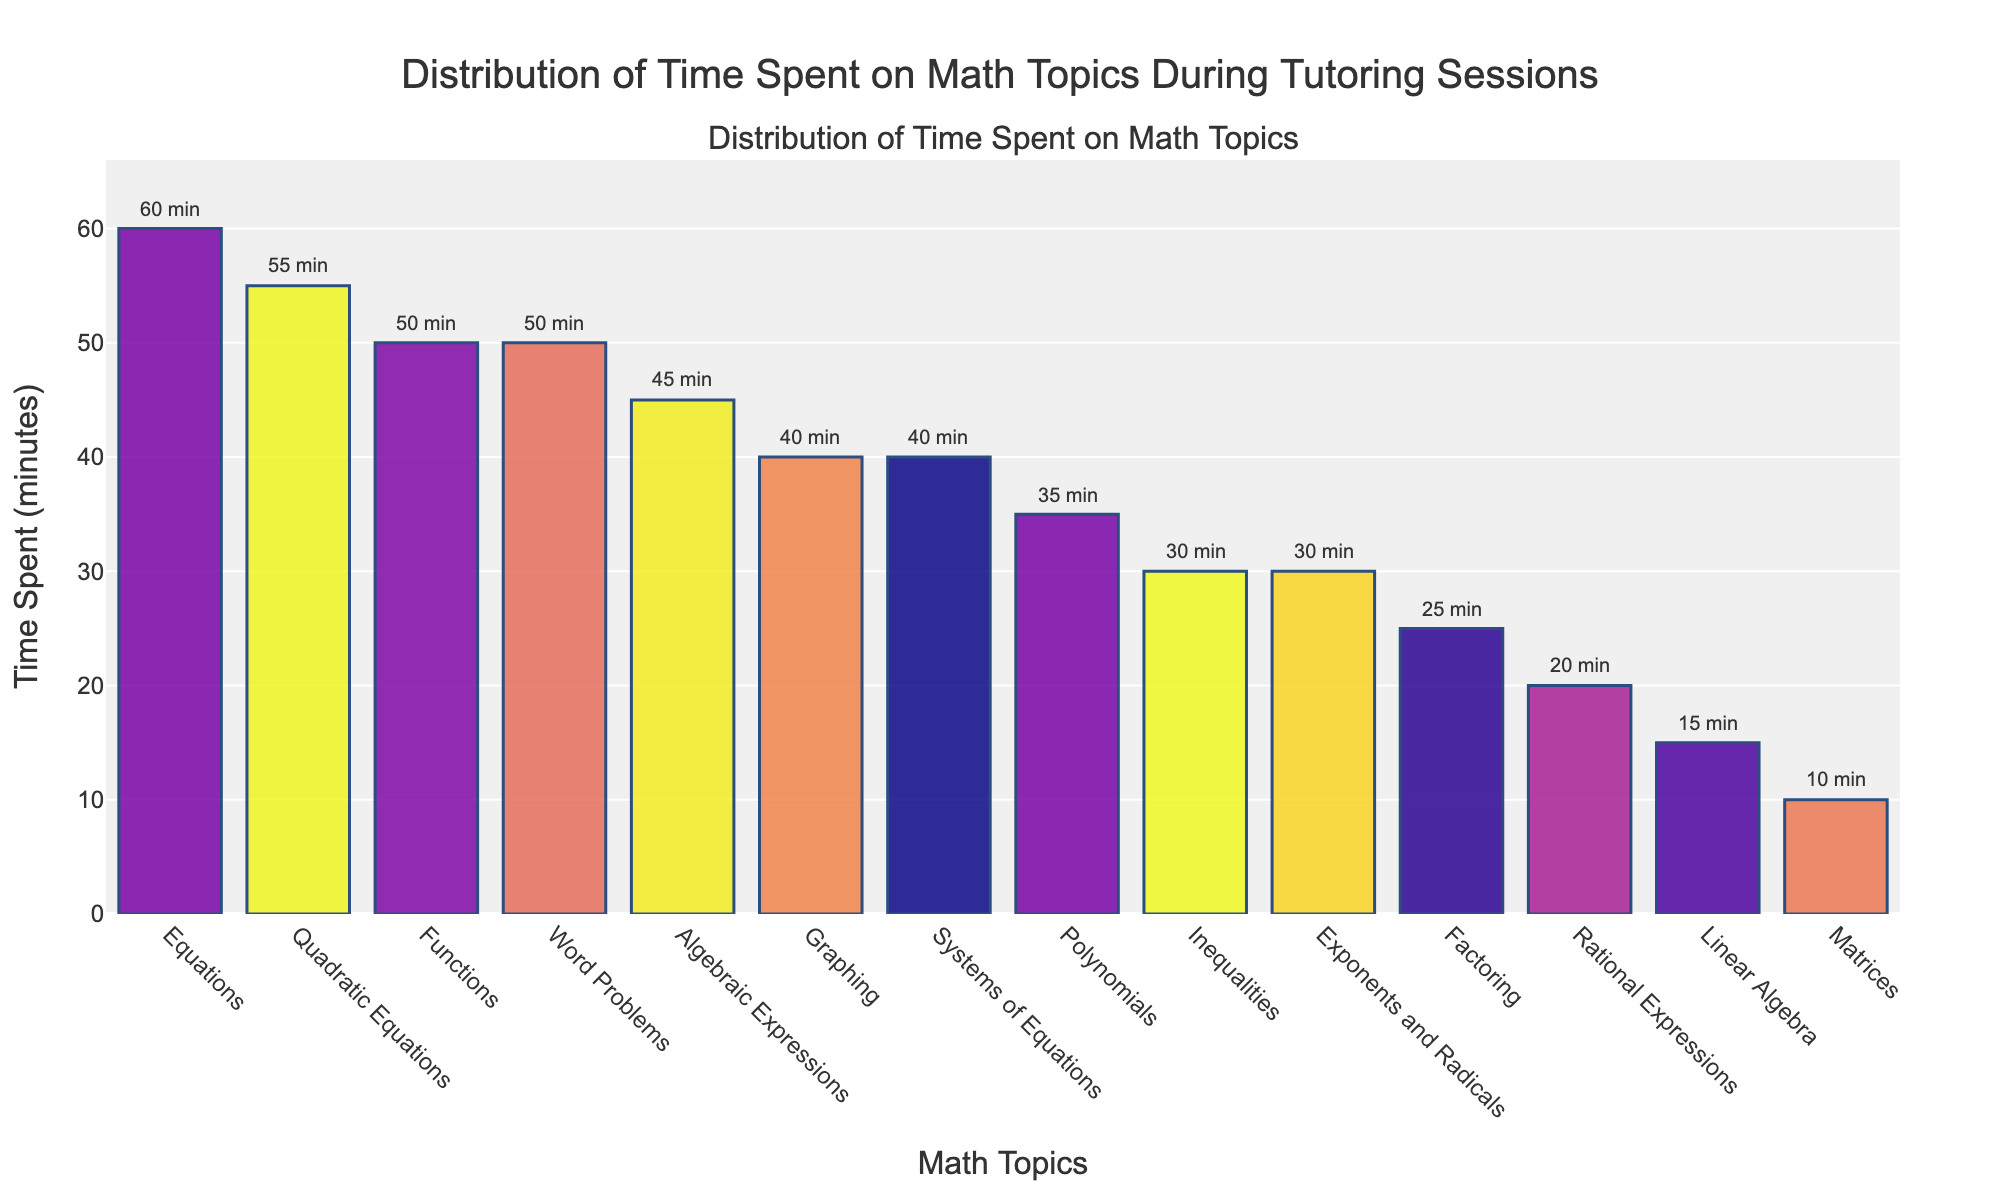What is the most time-consuming topic in the tutoring sessions? The bar representing Equations is the tallest, indicating the most time spent. The annotation shows 60 minutes.
Answer: Equations Which two topics have the same amount of time dedicated to them? Both Functions and Word Problems have bars of the same height, each annotated with 50 minutes.
Answer: Functions and Word Problems How many minutes in total are spent on Algebraic Expressions, Polynomials, and Graphing? Add the time for these topics: Algebraic Expressions (45 minutes) + Polynomials (35 minutes) + Graphing (40 minutes) = 120 minutes.
Answer: 120 minutes What's the difference in time spent between Quadratic Equations and Inequalities? The time spent on Quadratic Equations is 55 minutes and on Inequalities is 30 minutes. The difference is 55 - 30 = 25 minutes.
Answer: 25 minutes Which topic received the least amount of time, and how many minutes was it? The shortest bar corresponds to Matrices, annotated with 10 minutes.
Answer: Matrices, 10 minutes What is the combined time spent on the topics that are less than 30 minutes each? Add the time for Factoring (25), Rational Expressions (20), Linear Algebra (15), and Matrices (10): 25 + 20 + 15 + 10 = 70 minutes.
Answer: 70 minutes How much more time is spent on Systems of Equations compared to Rational Expressions? Systems of Equations have 40 minutes, and Rational Expressions have 20 minutes. The difference is 40 - 20 = 20 minutes.
Answer: 20 minutes If the time spent on Exponents and Radicals was doubled, what would the new total time be for this topic? The current time is 30 minutes. Doubled, it would be 30 * 2 = 60 minutes.
Answer: 60 minutes What is the average time spent on the three topics with the least amount of time? The three topics are Matrices (10), Linear Algebra (15), and Rational Expressions (20). The average is (10 + 15 + 20) / 3 = 15 minutes.
Answer: 15 minutes 